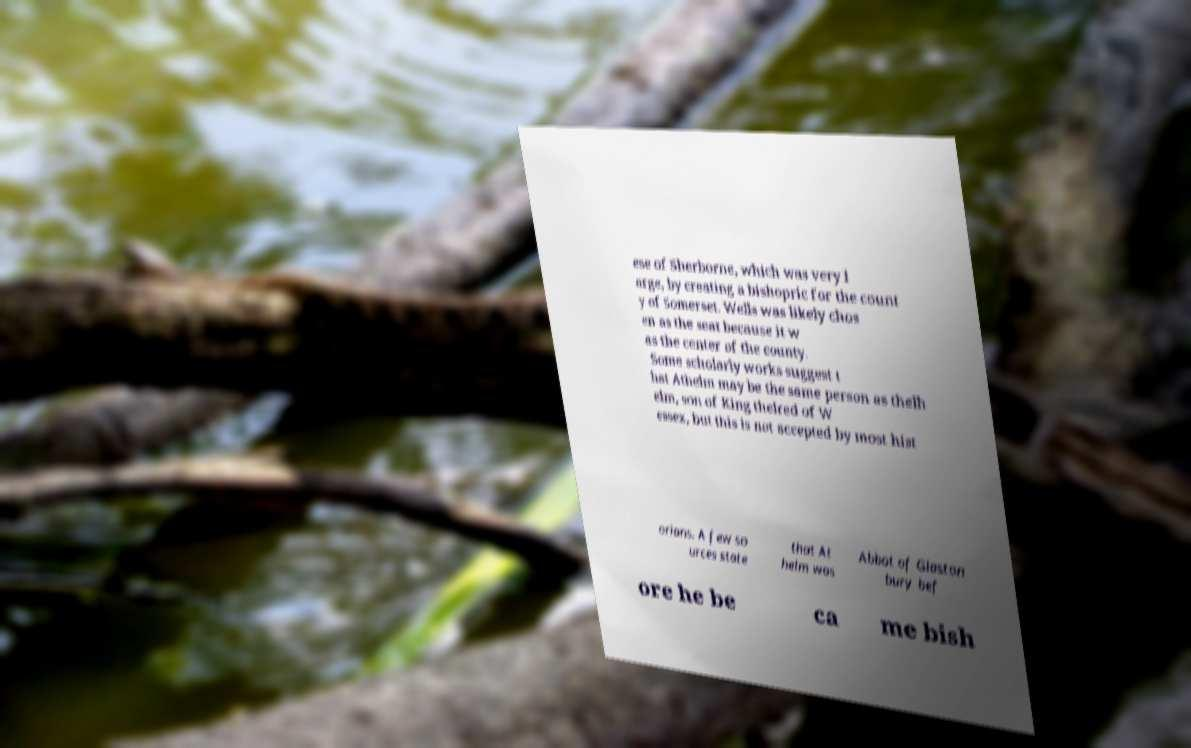Please read and relay the text visible in this image. What does it say? ese of Sherborne, which was very l arge, by creating a bishopric for the count y of Somerset. Wells was likely chos en as the seat because it w as the center of the county. Some scholarly works suggest t hat Athelm may be the same person as thelh elm, son of King thelred of W essex, but this is not accepted by most hist orians. A few so urces state that At helm was Abbot of Glaston bury bef ore he be ca me bish 